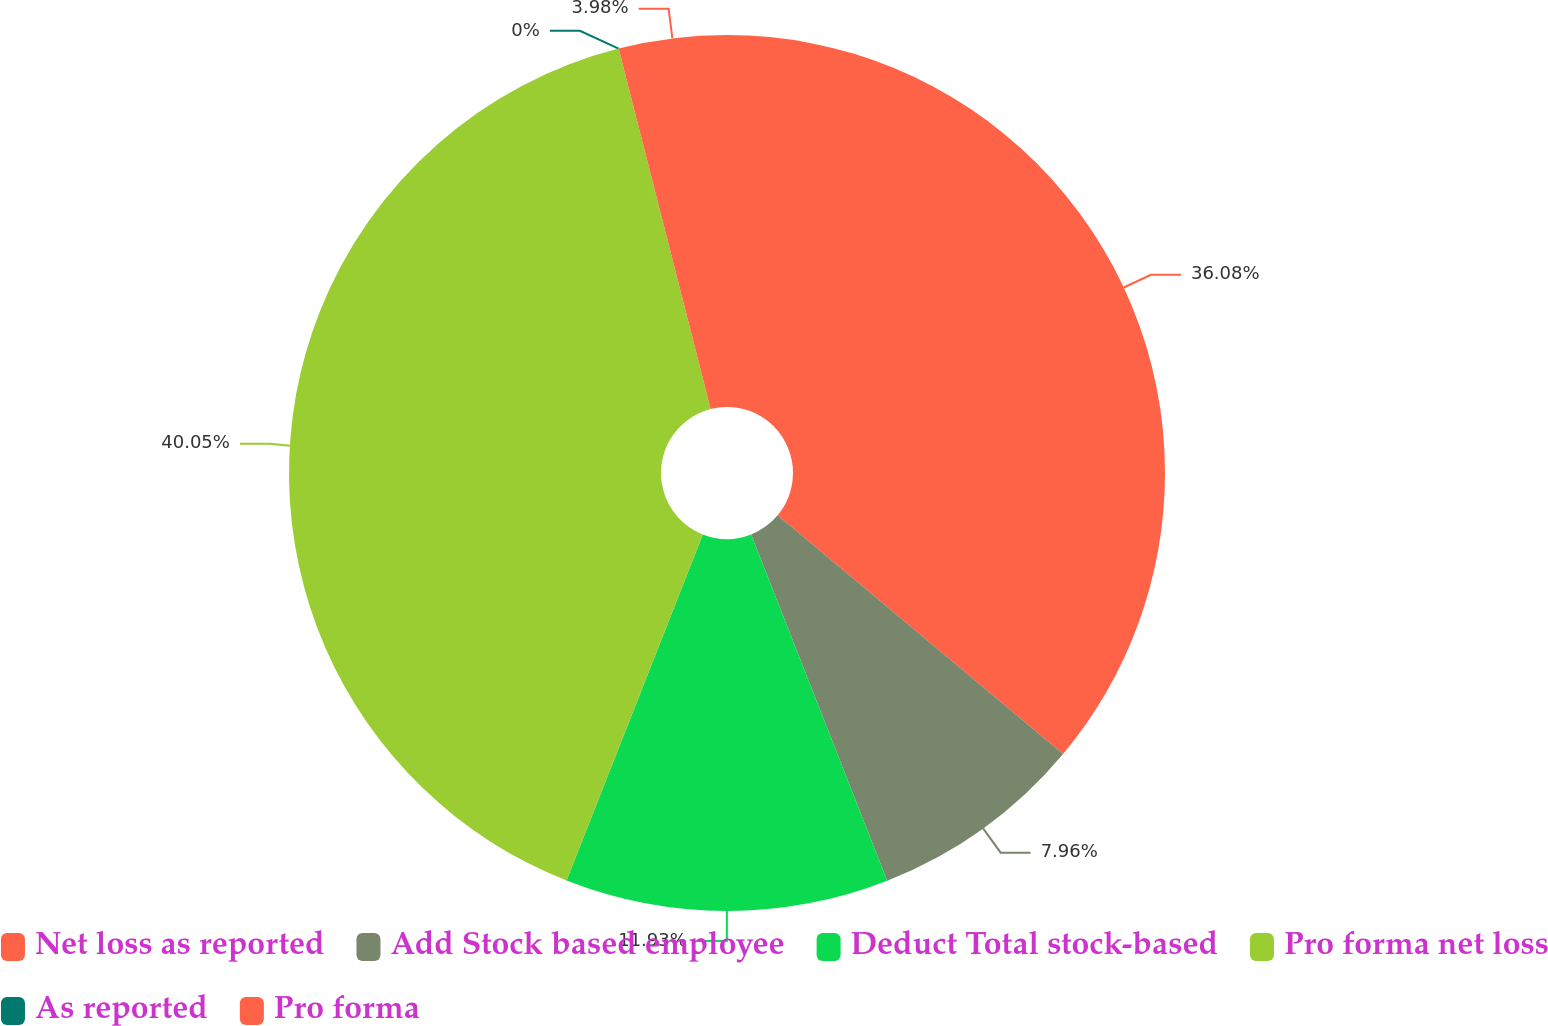<chart> <loc_0><loc_0><loc_500><loc_500><pie_chart><fcel>Net loss as reported<fcel>Add Stock based employee<fcel>Deduct Total stock-based<fcel>Pro forma net loss<fcel>As reported<fcel>Pro forma<nl><fcel>36.08%<fcel>7.96%<fcel>11.93%<fcel>40.05%<fcel>0.0%<fcel>3.98%<nl></chart> 